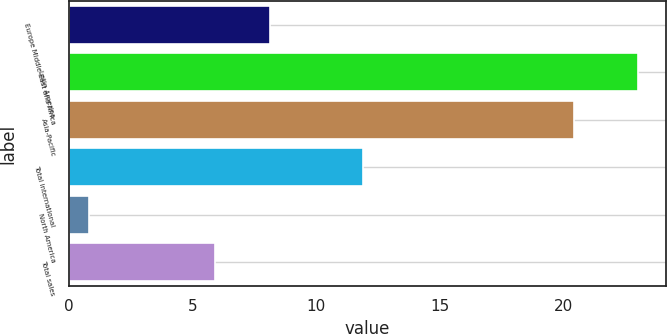<chart> <loc_0><loc_0><loc_500><loc_500><bar_chart><fcel>Europe Middle East and Africa<fcel>Latin America<fcel>Asia-Pacific<fcel>Total international<fcel>North America<fcel>Total sales<nl><fcel>8.12<fcel>23<fcel>20.4<fcel>11.9<fcel>0.8<fcel>5.9<nl></chart> 